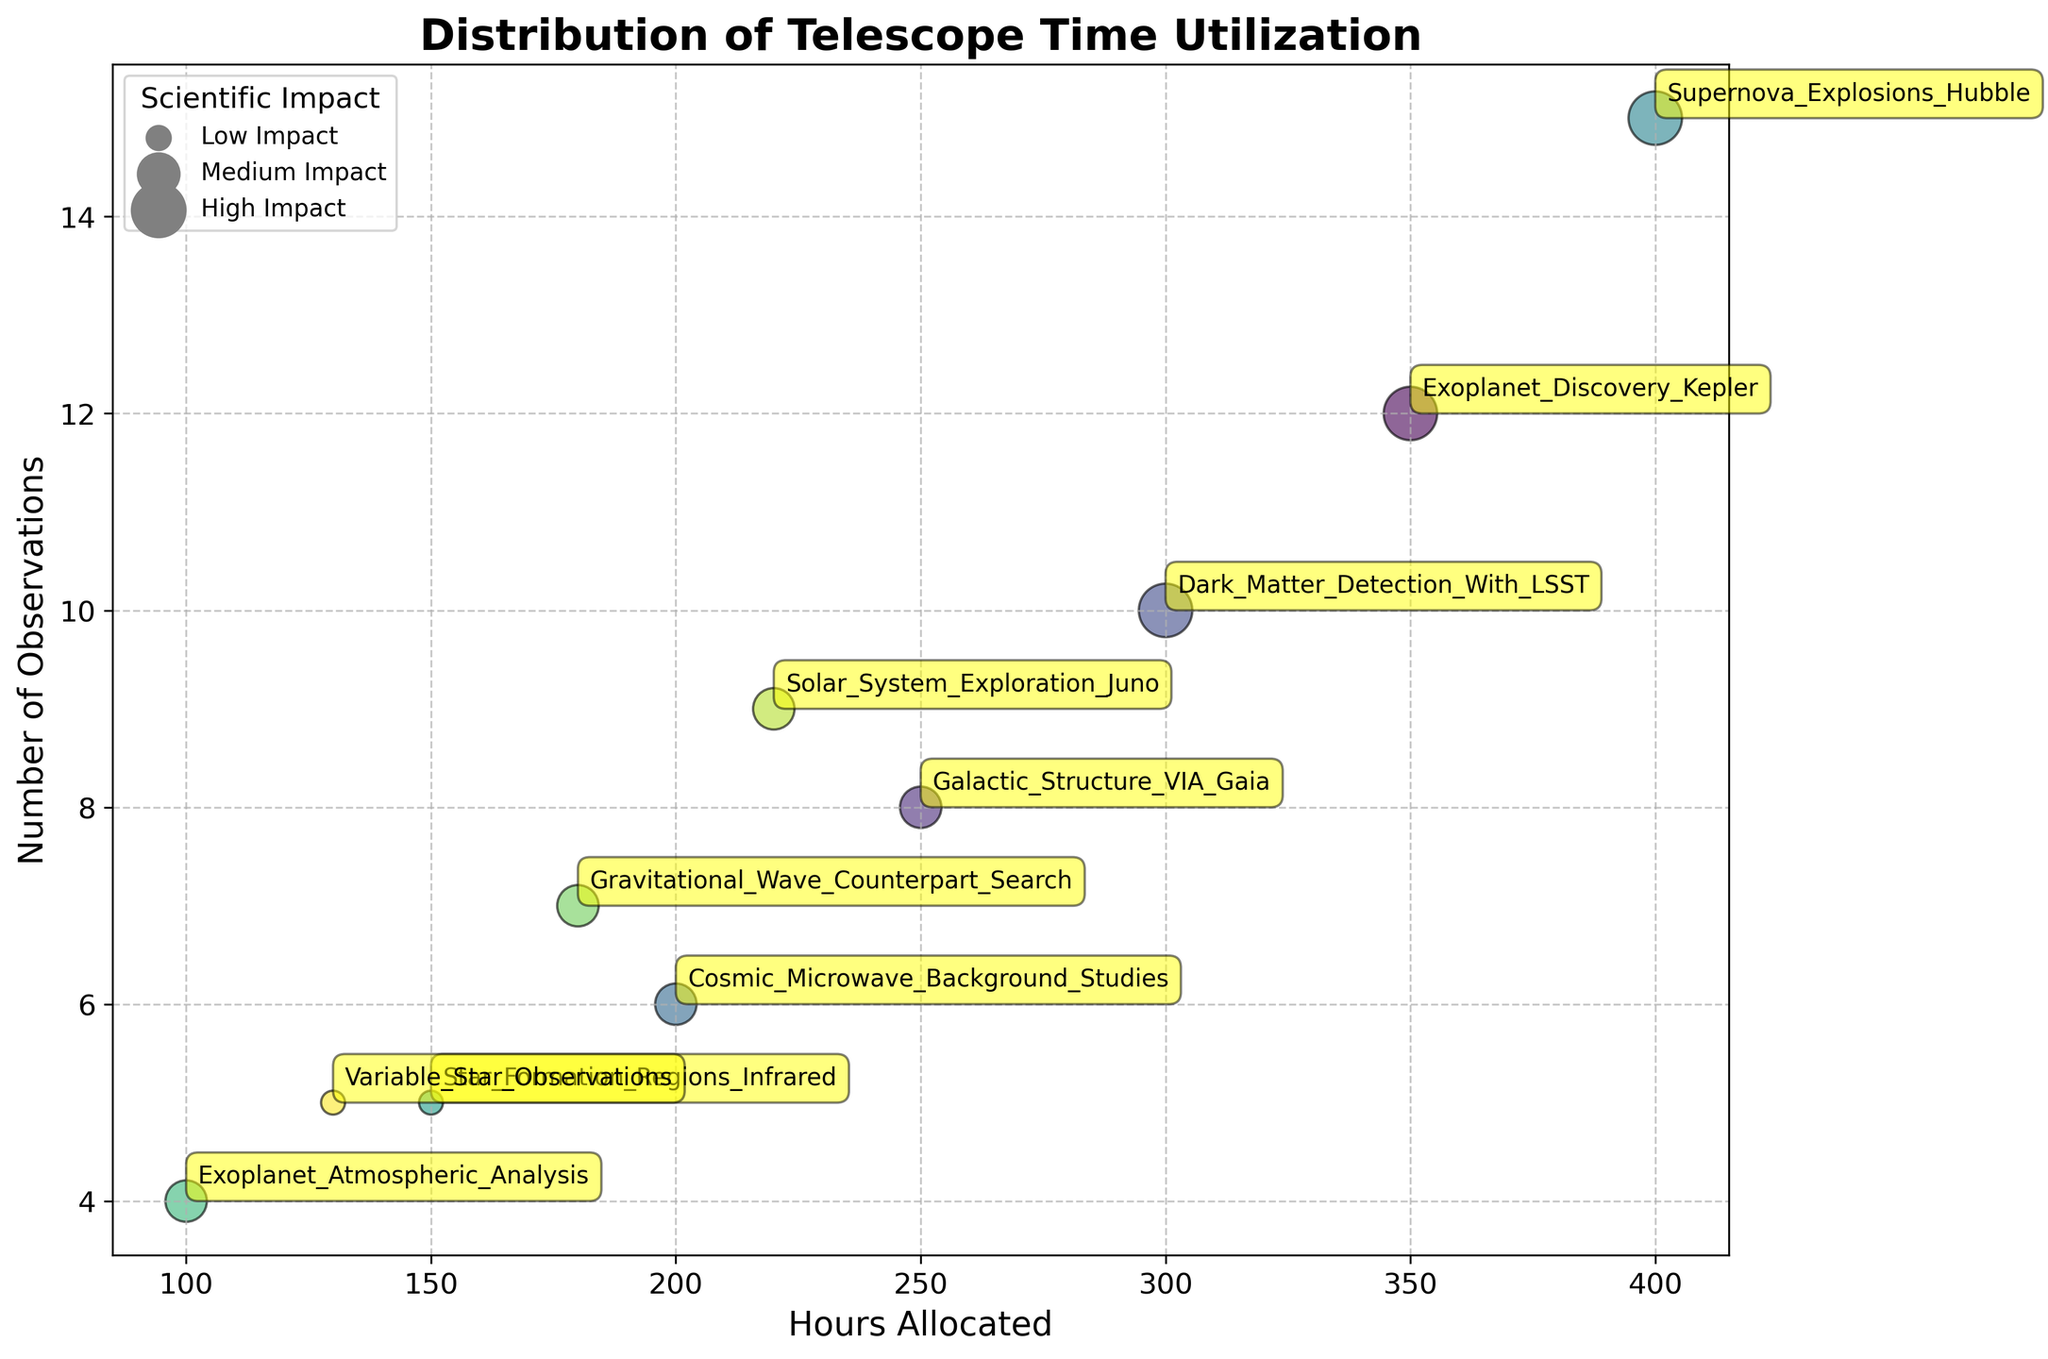What's the title of the chart? The title of the chart is positioned at the top of the figure.
Answer: Distribution of Telescope Time Utilization How many data points represent projects with high scientific impact? The scientific impact is visualized by bubble size. High impact is indicated by the largest bubbles. There are three large bubbles.
Answer: 3 Which project has the highest number of observations? The project with the highest number of observations will be at the highest point on the y-axis. The highest point corresponds to "Supernova Explosions Hubble" with 15 observations.
Answer: Supernova Explosions Hubble How many hours are allocated to Exoplanet Discovery Kepler compared to Galactic Structure VIA Gaia? Refer to the x-axis values for both projects. Exoplanet Discovery Kepler has 350 hours, and Galactic Structure VIA Gaia has 250 hours. The difference is 350 - 250.
Answer: 100 hours Which project has the smallest bubble? The smallest bubble represents the projects with low scientific impact. Look for the smallest bubbles on the chart. "Star Formation Regions Infrared" and "Variable Star Observations" have the smallest bubbles.
Answer: Star Formation Regions Infrared and Variable Star Observations What is the range of hours allocated across all projects on the x-axis? To find the range, identify the maximum and minimum values on the x-axis. The maximum is 400 hours (Supernova Explosions Hubble), and the minimum is 100 hours (Exoplanet Atmospheric Analysis). The range is 400 - 100.
Answer: 300 hours Does any project with medium scientific impact have more observations than Dark Matter Detection With LSST? Dark Matter Detection With LSST has 10 observations. By looking at the bubble sizes and y-axis values for medium impact projects, none exceed 10 observations. This means no medium impact project has more observations than Dark Matter Detection With LSST.
Answer: No Compare the hours allocated for the two projects with the smallest number of observations. The two projects with the smallest number of observations have 4 and 5 observations respectively. "Exoplanet Atmospheric Analysis" has 4 observations with 100 hours, and "Star Formation Regions Infrared" has 5 observations with 150 hours.
Answer: Exoplanet Atmospheric Analysis: 100 hours, Star Formation Regions Infrared: 150 hours What is the total number of observations for all low scientific impact projects? There are two low impact projects: "Star Formation Regions Infrared" with 5 observations and "Variable Star Observations" with 5 observations. Summing these gives 5 + 5.
Answer: 10 Which project has been allocated the least observation time (hours)? The project with the lowest x-axis value will have the least time allocated. "Exoplanet Atmospheric Analysis" is at the lowest x-axis position with 100 hours allocated.
Answer: Exoplanet Atmospheric Analysis 